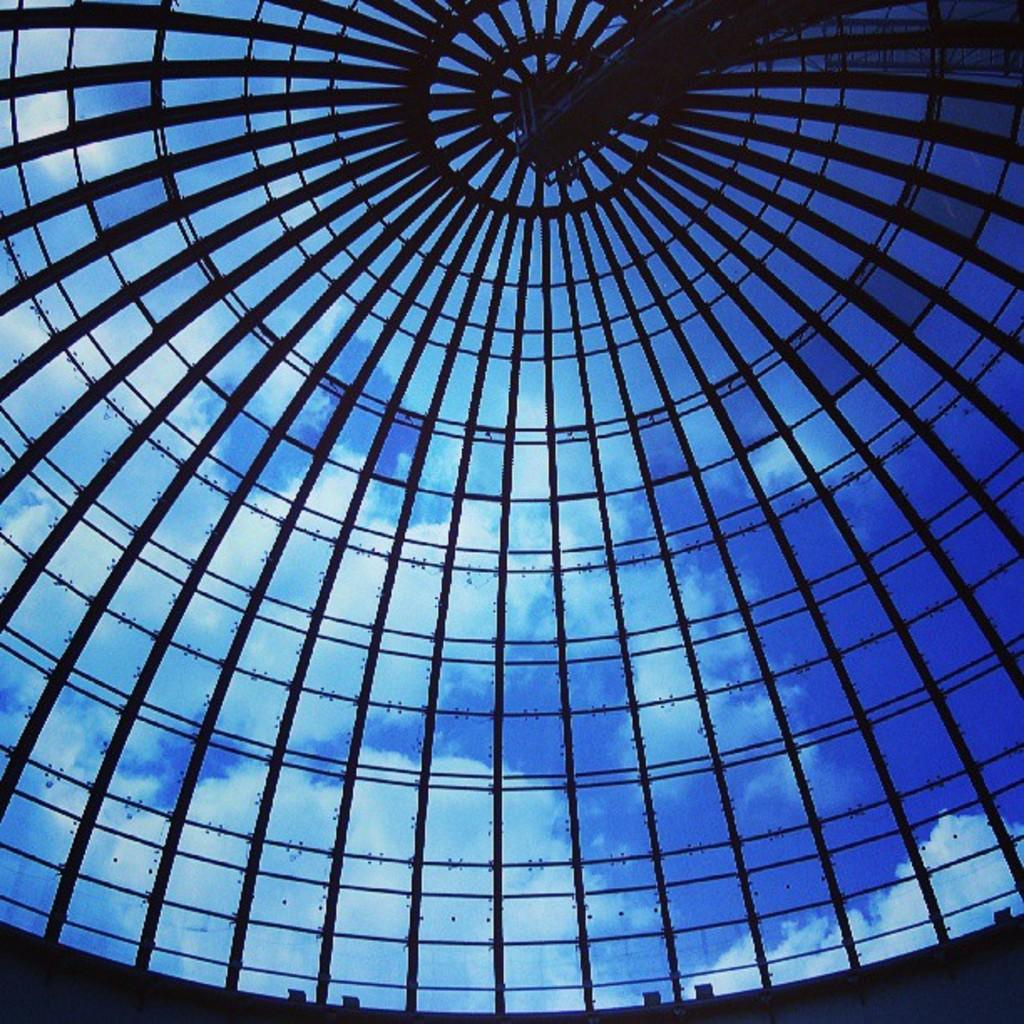What material is used for the ceiling of the building in the image? The ceiling of the building is made of glass. What can be seen through the glass ceiling? The sky is visible through the glass ceiling. What type of flame can be seen burning in the cave in the image? There is no cave or flame present in the image; it features a glass ceiling and the sky. What kind of meat is being prepared on the grill in the image? There is no grill or meat present in the image; it only shows a glass ceiling and the sky. 